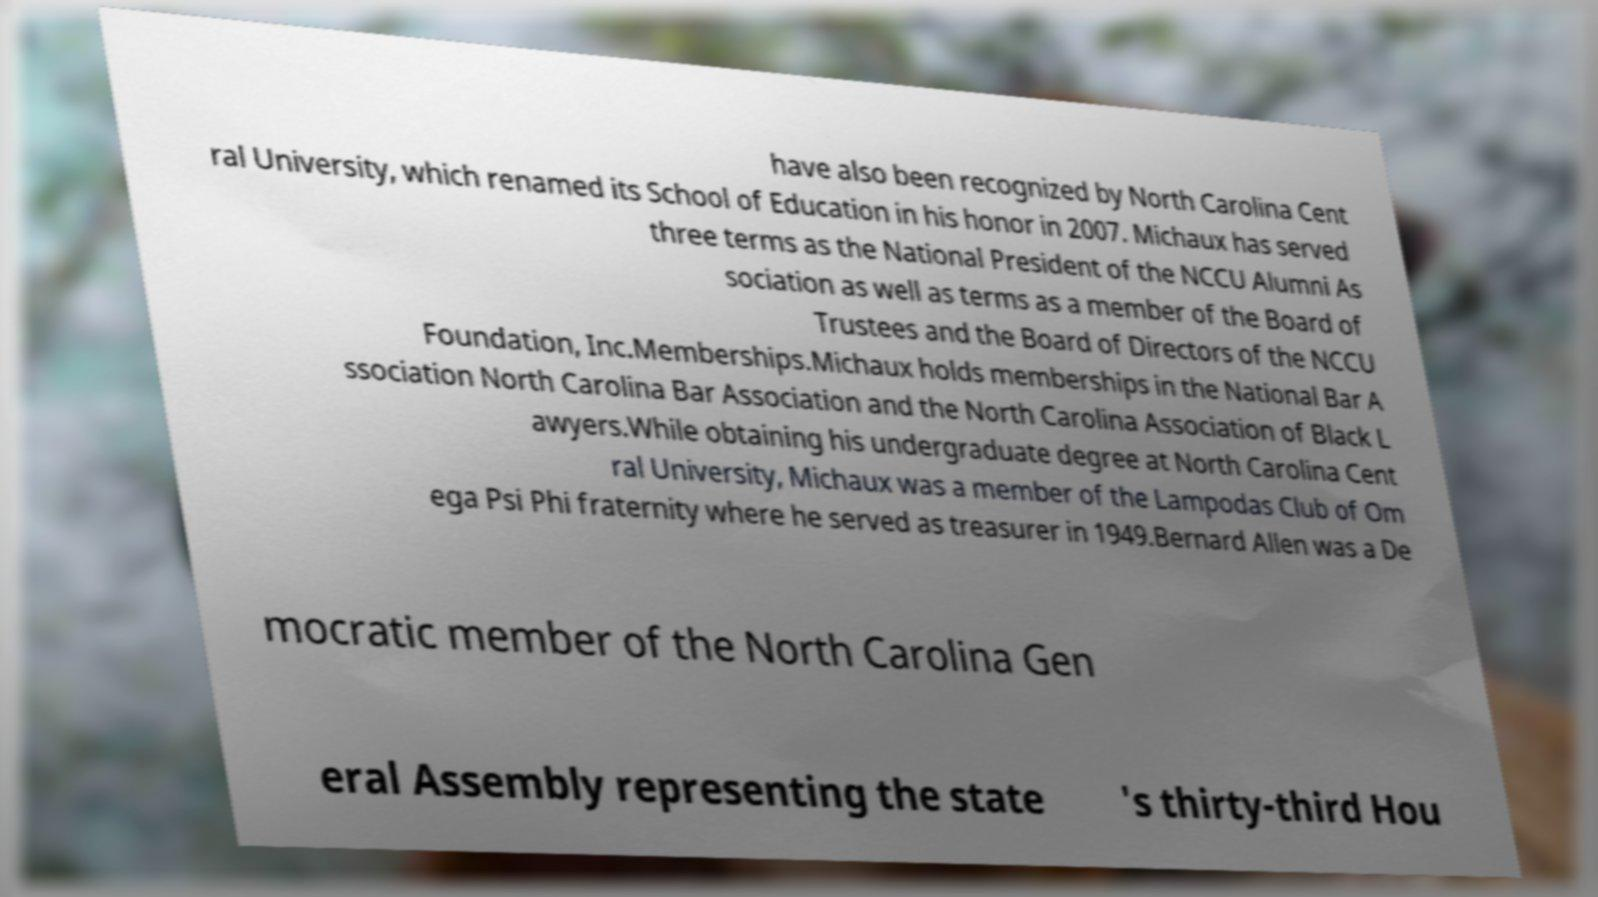Please identify and transcribe the text found in this image. have also been recognized by North Carolina Cent ral University, which renamed its School of Education in his honor in 2007. Michaux has served three terms as the National President of the NCCU Alumni As sociation as well as terms as a member of the Board of Trustees and the Board of Directors of the NCCU Foundation, Inc.Memberships.Michaux holds memberships in the National Bar A ssociation North Carolina Bar Association and the North Carolina Association of Black L awyers.While obtaining his undergraduate degree at North Carolina Cent ral University, Michaux was a member of the Lampodas Club of Om ega Psi Phi fraternity where he served as treasurer in 1949.Bernard Allen was a De mocratic member of the North Carolina Gen eral Assembly representing the state 's thirty-third Hou 